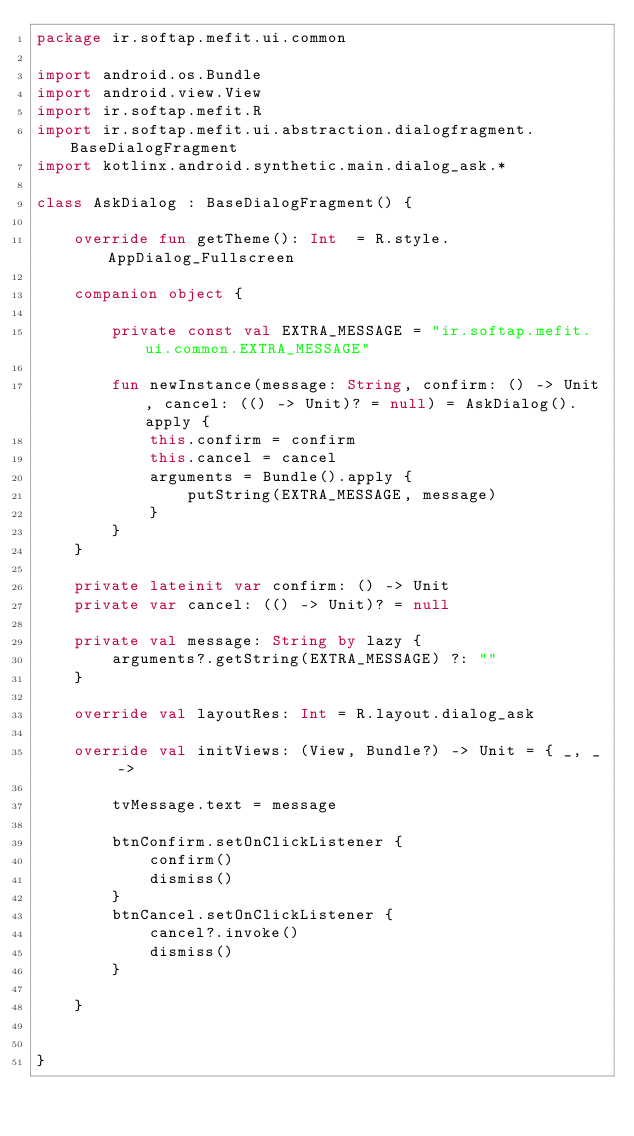<code> <loc_0><loc_0><loc_500><loc_500><_Kotlin_>package ir.softap.mefit.ui.common

import android.os.Bundle
import android.view.View
import ir.softap.mefit.R
import ir.softap.mefit.ui.abstraction.dialogfragment.BaseDialogFragment
import kotlinx.android.synthetic.main.dialog_ask.*

class AskDialog : BaseDialogFragment() {

    override fun getTheme(): Int  = R.style.AppDialog_Fullscreen

    companion object {

        private const val EXTRA_MESSAGE = "ir.softap.mefit.ui.common.EXTRA_MESSAGE"

        fun newInstance(message: String, confirm: () -> Unit, cancel: (() -> Unit)? = null) = AskDialog().apply {
            this.confirm = confirm
            this.cancel = cancel
            arguments = Bundle().apply {
                putString(EXTRA_MESSAGE, message)
            }
        }
    }

    private lateinit var confirm: () -> Unit
    private var cancel: (() -> Unit)? = null

    private val message: String by lazy {
        arguments?.getString(EXTRA_MESSAGE) ?: ""
    }

    override val layoutRes: Int = R.layout.dialog_ask

    override val initViews: (View, Bundle?) -> Unit = { _, _ ->

        tvMessage.text = message

        btnConfirm.setOnClickListener {
            confirm()
            dismiss()
        }
        btnCancel.setOnClickListener {
            cancel?.invoke()
            dismiss()
        }

    }


}</code> 